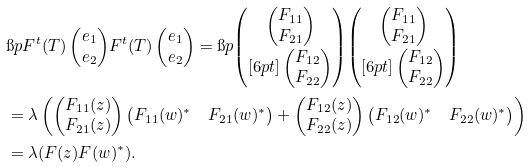Convert formula to latex. <formula><loc_0><loc_0><loc_500><loc_500>& \i p { F ^ { t } ( T ) \begin{pmatrix} e _ { 1 } \\ e _ { 2 } \end{pmatrix} } { F ^ { t } ( T ) \begin{pmatrix} e _ { 1 } \\ e _ { 2 } \end{pmatrix} } = \i p { \begin{pmatrix} \begin{pmatrix} F _ { 1 1 } \\ F _ { 2 1 } \end{pmatrix} \\ [ 6 p t ] \begin{pmatrix} F _ { 1 2 } \\ F _ { 2 2 } \end{pmatrix} \end{pmatrix} } { \begin{pmatrix} \begin{pmatrix} F _ { 1 1 } \\ F _ { 2 1 } \end{pmatrix} \\ [ 6 p t ] \begin{pmatrix} F _ { 1 2 } \\ F _ { 2 2 } \end{pmatrix} \end{pmatrix} } \\ & = \lambda \left ( \begin{pmatrix} F _ { 1 1 } ( z ) \\ F _ { 2 1 } ( z ) \end{pmatrix} \begin{pmatrix} F _ { 1 1 } ( w ) ^ { * } & F _ { 2 1 } ( w ) ^ { * } \end{pmatrix} + \begin{pmatrix} F _ { 1 2 } ( z ) \\ F _ { 2 2 } ( z ) \end{pmatrix} \begin{pmatrix} F _ { 1 2 } ( w ) ^ { * } & F _ { 2 2 } ( w ) ^ { * } \end{pmatrix} \right ) \\ & = \lambda ( F ( z ) F ( w ) ^ { * } ) .</formula> 